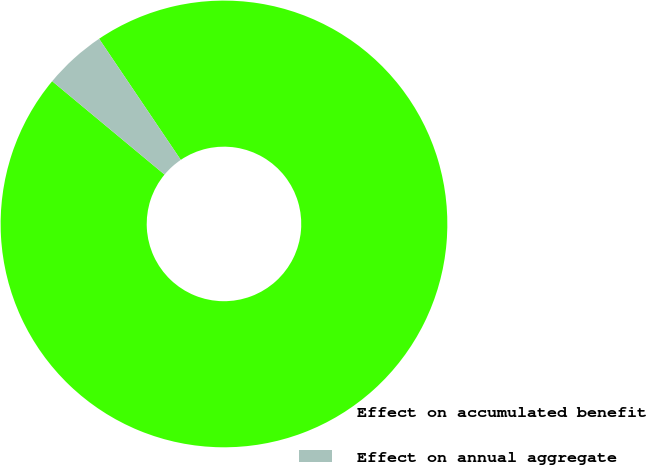Convert chart to OTSL. <chart><loc_0><loc_0><loc_500><loc_500><pie_chart><fcel>Effect on accumulated benefit<fcel>Effect on annual aggregate<nl><fcel>95.48%<fcel>4.52%<nl></chart> 